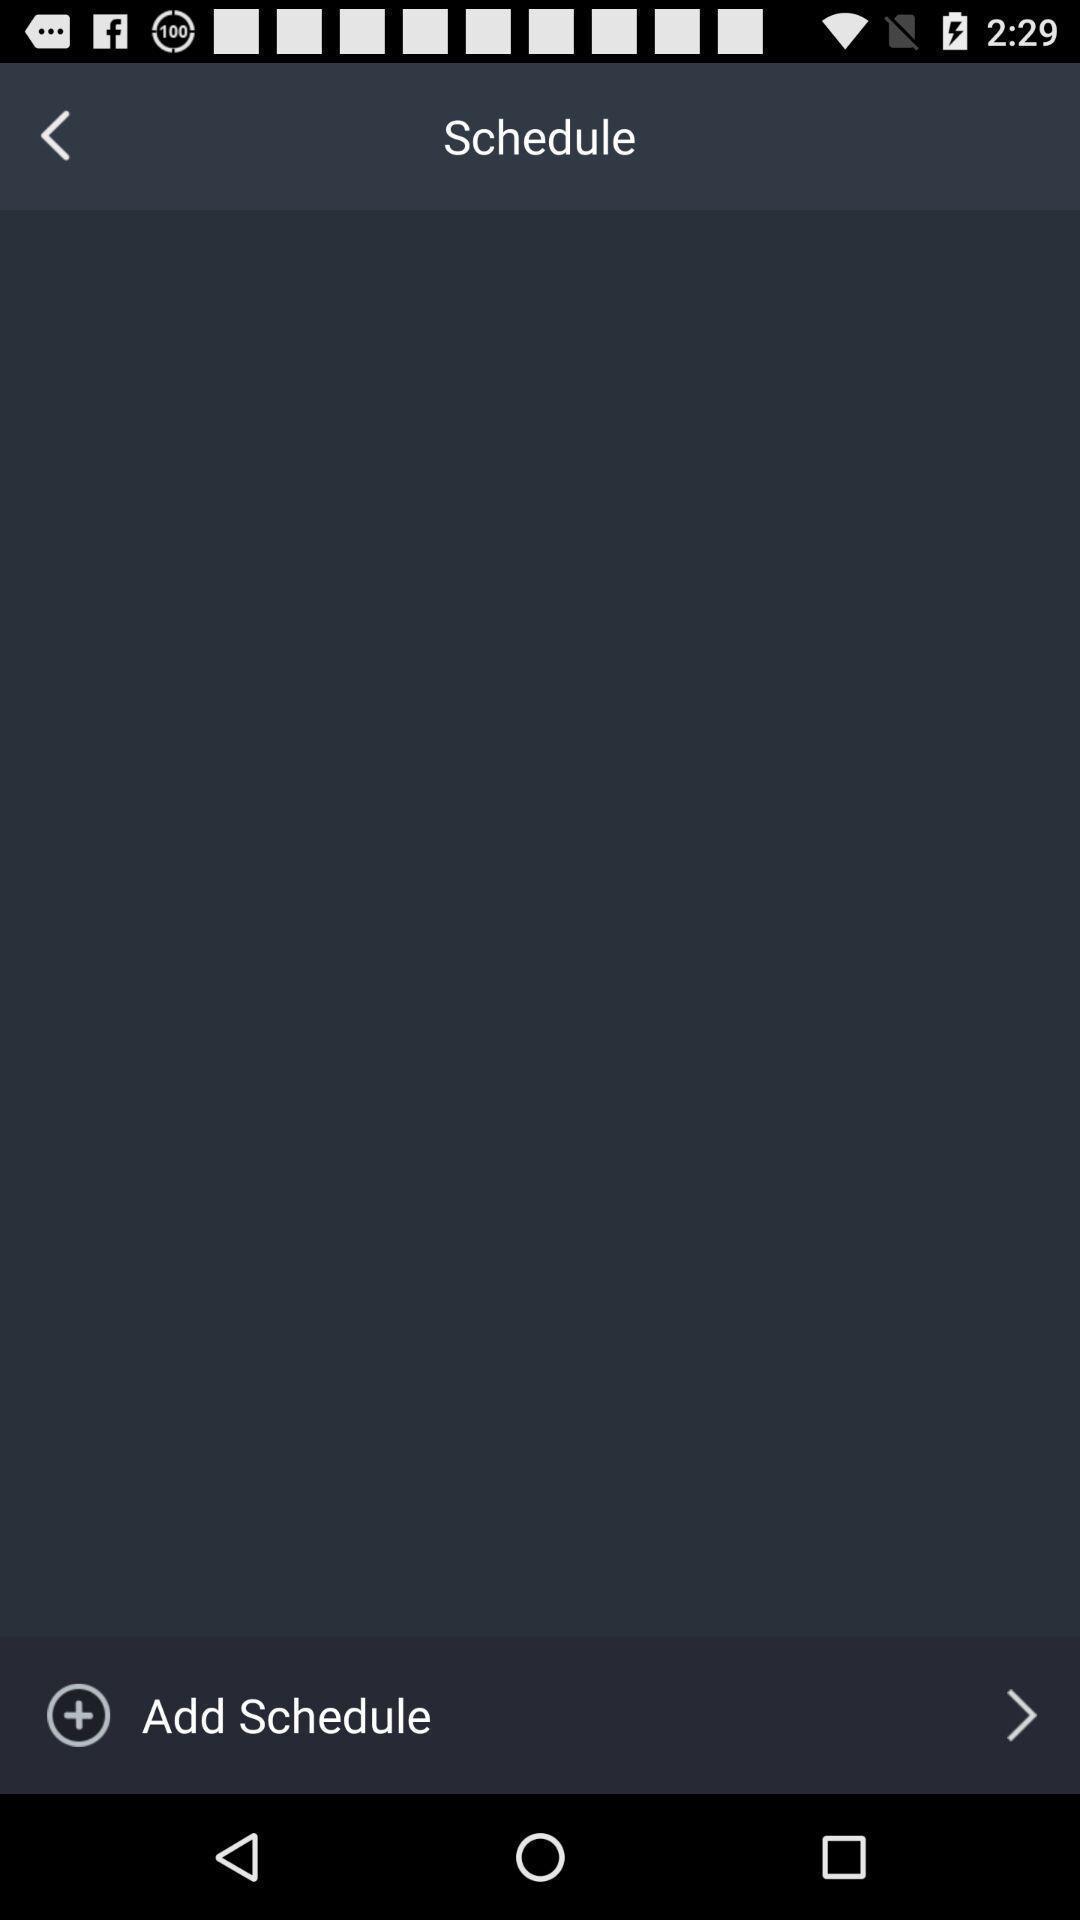Describe the content in this image. Page showing add schedule option. 